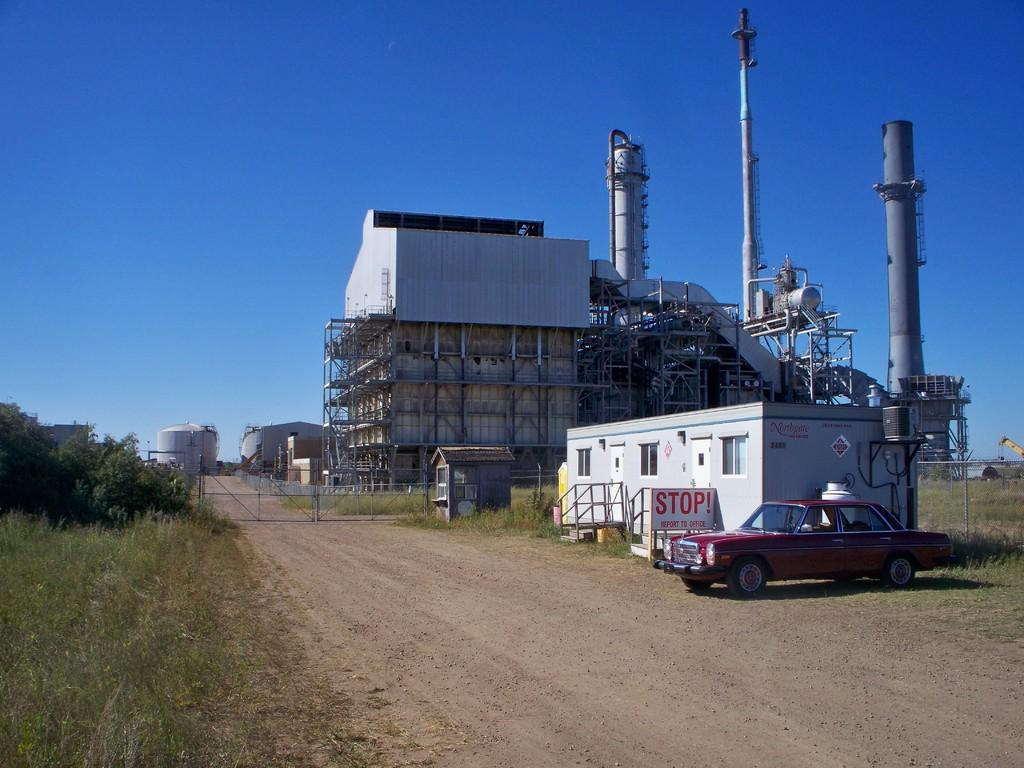What type of vehicle is in the right corner of the image? There is a red color car in the right corner of the image. What is located beside the car? There is a house beside the car. What can be seen in the background of the image? There is a factory in the background of the image. What is the color of the sky in the image? The sky is blue in color. How many cakes are being regretted by the car in the image? There are no cakes or any indication of regret present in the image. 